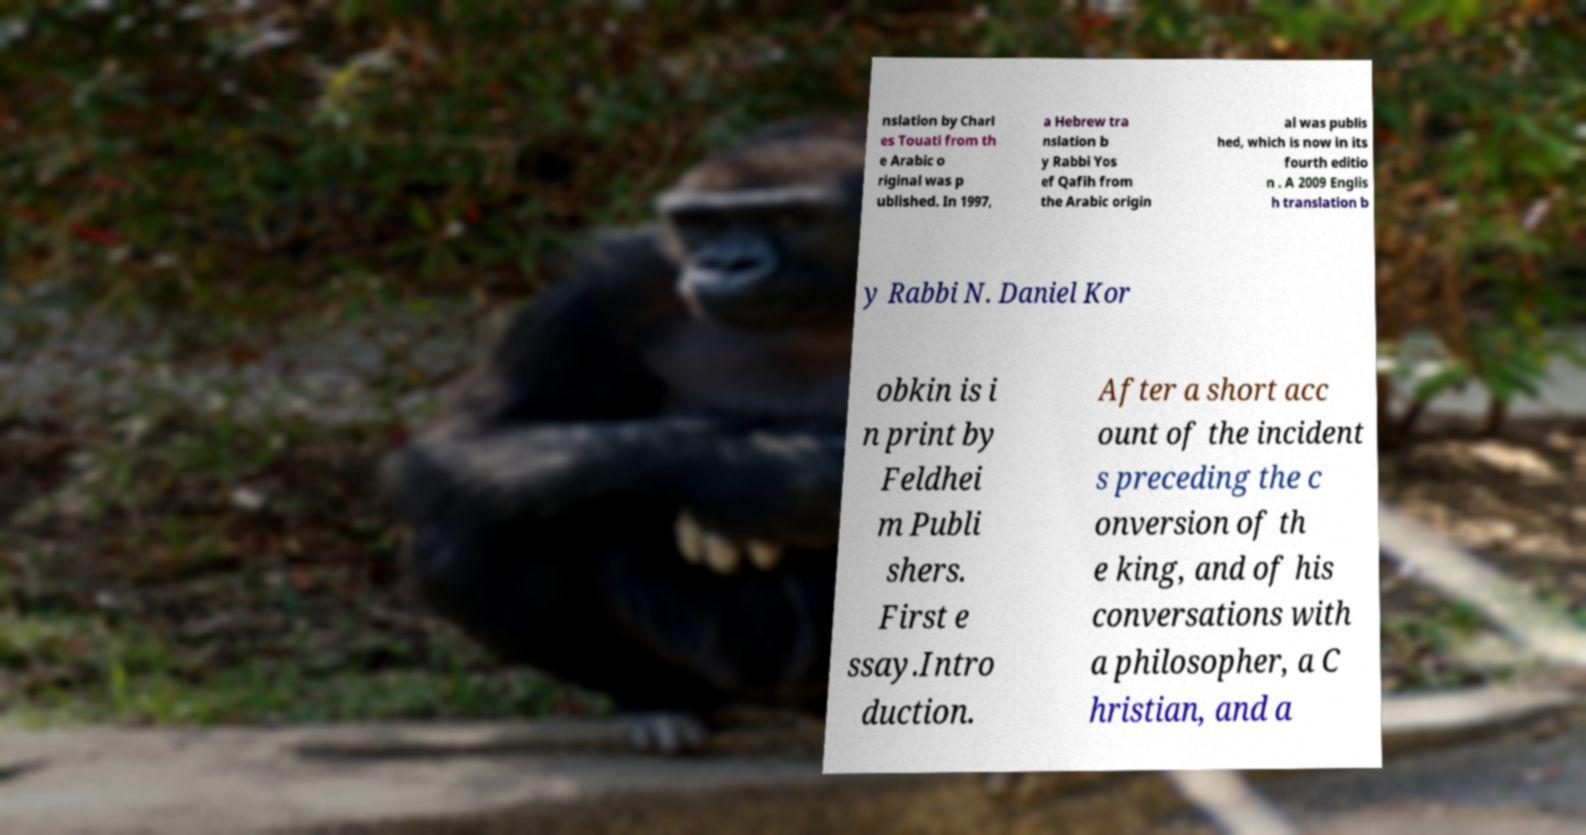Please read and relay the text visible in this image. What does it say? nslation by Charl es Touati from th e Arabic o riginal was p ublished. In 1997, a Hebrew tra nslation b y Rabbi Yos ef Qafih from the Arabic origin al was publis hed, which is now in its fourth editio n . A 2009 Englis h translation b y Rabbi N. Daniel Kor obkin is i n print by Feldhei m Publi shers. First e ssay.Intro duction. After a short acc ount of the incident s preceding the c onversion of th e king, and of his conversations with a philosopher, a C hristian, and a 